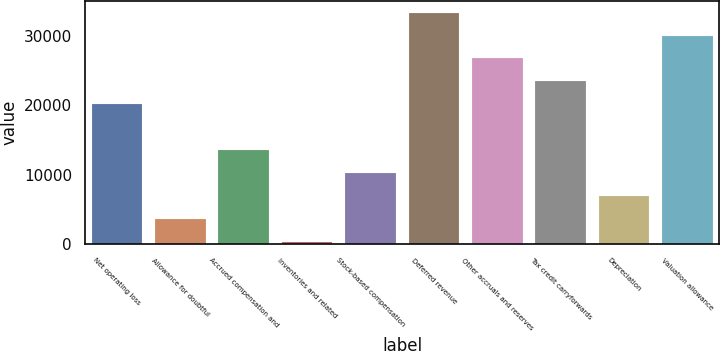<chart> <loc_0><loc_0><loc_500><loc_500><bar_chart><fcel>Net operating loss<fcel>Allowance for doubtful<fcel>Accrued compensation and<fcel>Inventories and related<fcel>Stock-based compensation<fcel>Deferred revenue<fcel>Other accruals and reserves<fcel>Tax credit carryforwards<fcel>Depreciation<fcel>Valuation allowance<nl><fcel>20173.2<fcel>3632.2<fcel>13556.8<fcel>324<fcel>10248.6<fcel>33406<fcel>26789.6<fcel>23481.4<fcel>6940.4<fcel>30097.8<nl></chart> 